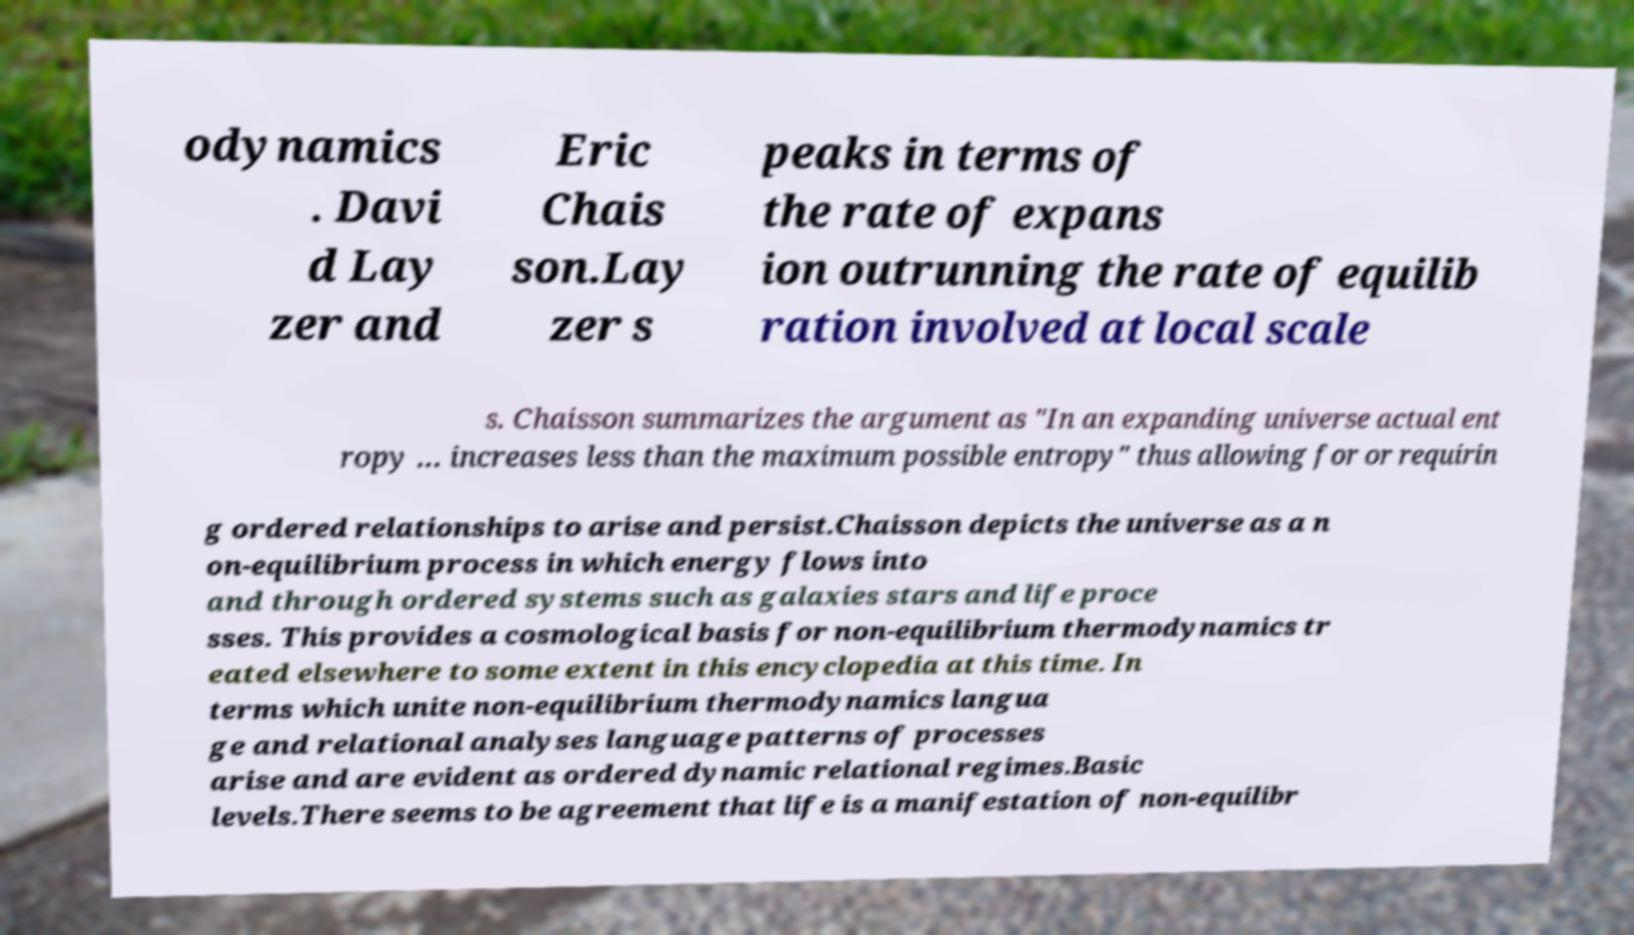Can you accurately transcribe the text from the provided image for me? odynamics . Davi d Lay zer and Eric Chais son.Lay zer s peaks in terms of the rate of expans ion outrunning the rate of equilib ration involved at local scale s. Chaisson summarizes the argument as "In an expanding universe actual ent ropy … increases less than the maximum possible entropy" thus allowing for or requirin g ordered relationships to arise and persist.Chaisson depicts the universe as a n on-equilibrium process in which energy flows into and through ordered systems such as galaxies stars and life proce sses. This provides a cosmological basis for non-equilibrium thermodynamics tr eated elsewhere to some extent in this encyclopedia at this time. In terms which unite non-equilibrium thermodynamics langua ge and relational analyses language patterns of processes arise and are evident as ordered dynamic relational regimes.Basic levels.There seems to be agreement that life is a manifestation of non-equilibr 